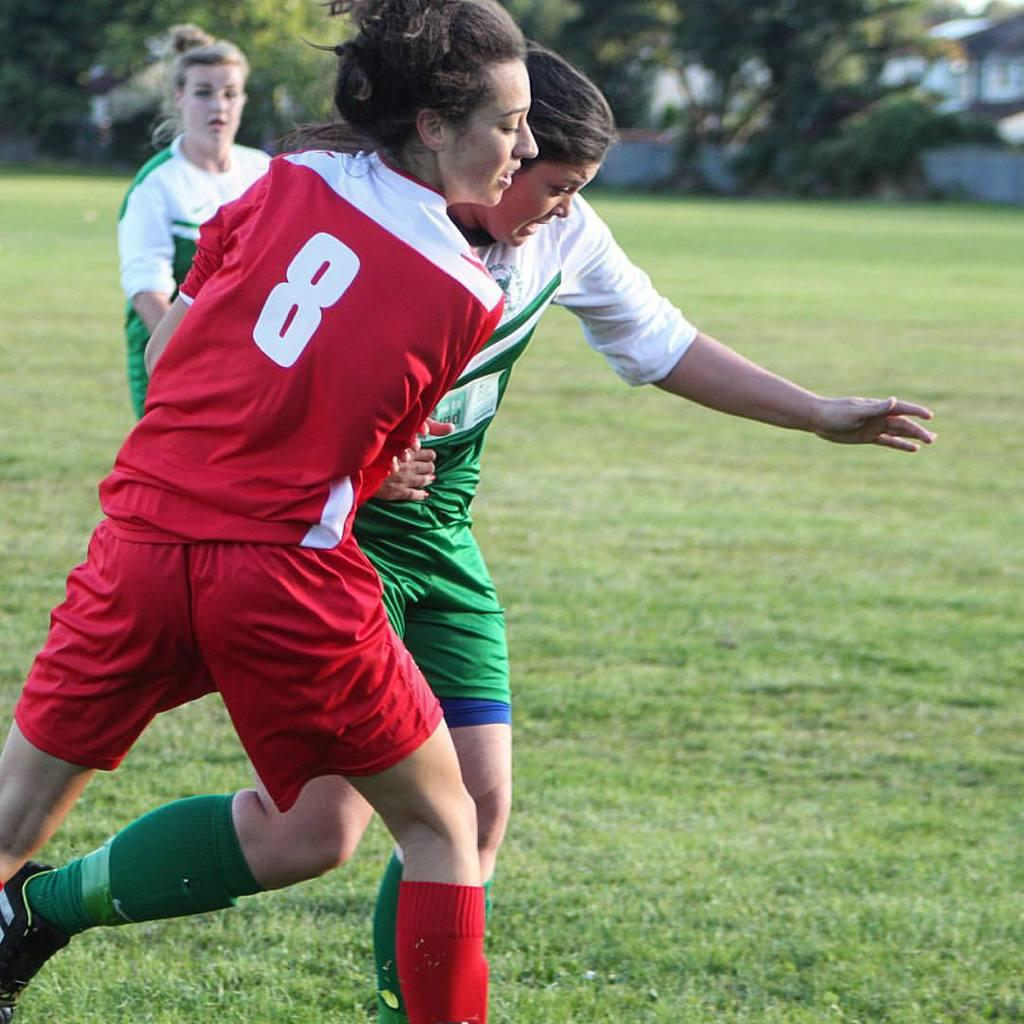<image>
Present a compact description of the photo's key features. Two female soccer players battling for ball and one stands in background and red team has 8 on jersey. 